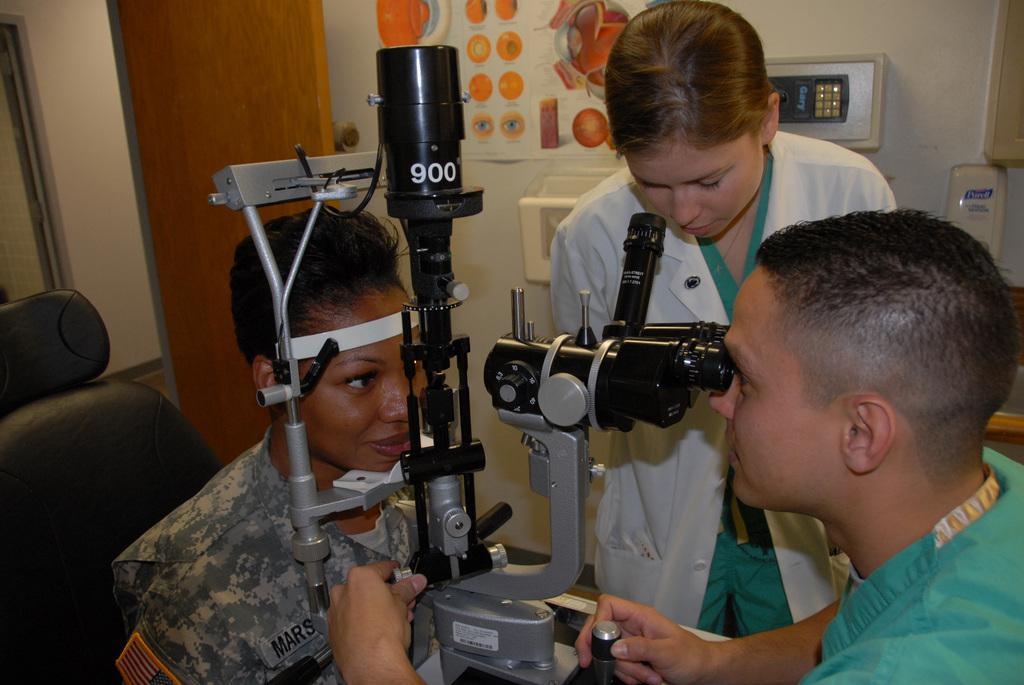Describe this image in one or two sentences. There are three people and this person sitting on chair, in between these two people we can see equipment. Background we can see poster on a wall. 